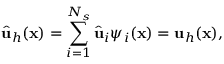Convert formula to latex. <formula><loc_0><loc_0><loc_500><loc_500>\widehat { u } _ { h } ( x ) = \sum _ { i = 1 } ^ { N _ { s } } \widehat { u } _ { i } { \psi } _ { i } ( x ) = u _ { h } ( x ) ,</formula> 